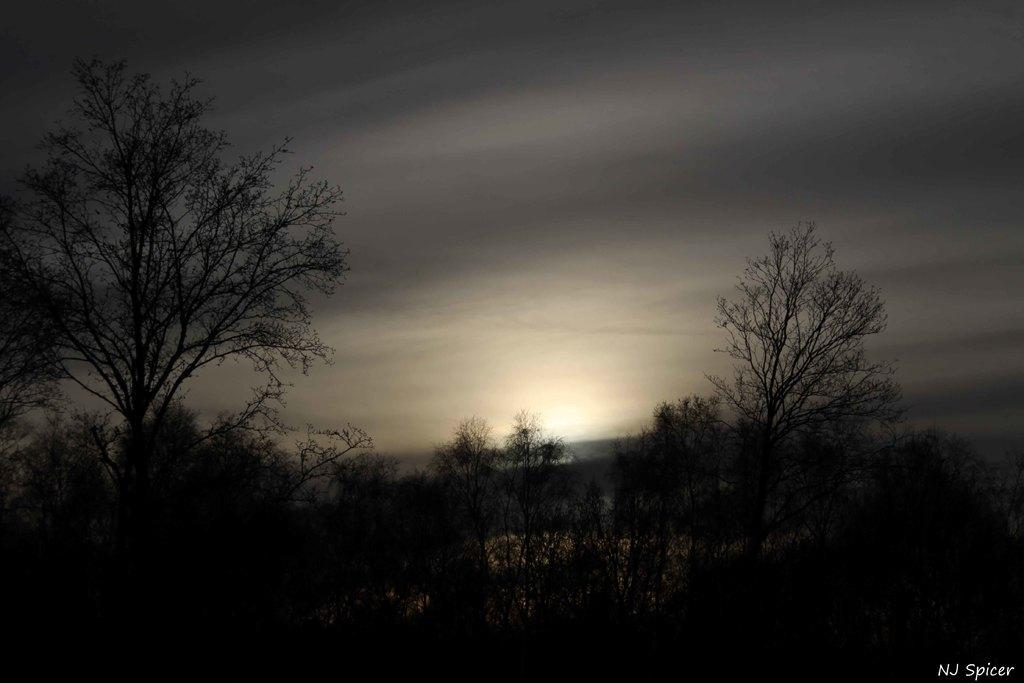What type of vegetation can be seen in the image? There are trees in the image. What is visible in the background of the image? The sky is visible in the image. What colors can be observed in the sky? The sky has a white and grey color. Can you hear the snails communicating with each other in the image? There are no snails present in the image, so it is not possible to hear them communicating. 